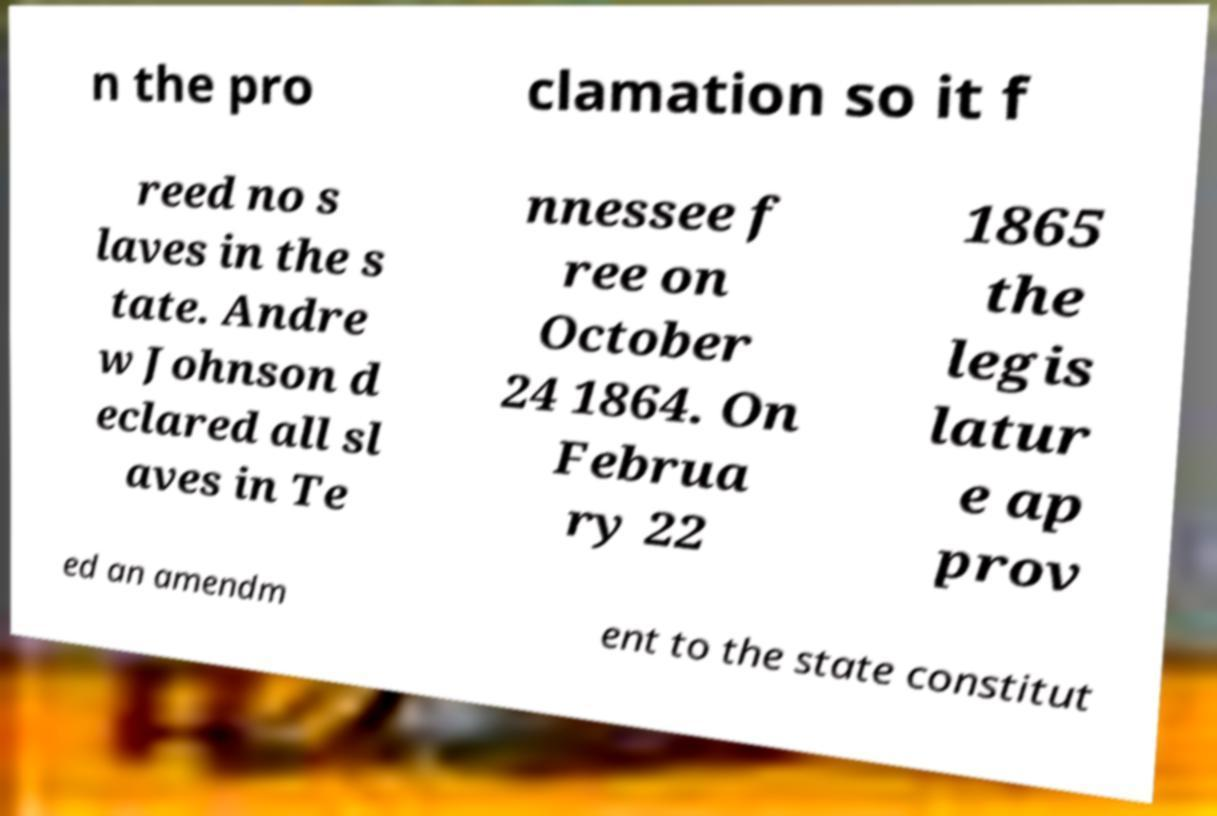For documentation purposes, I need the text within this image transcribed. Could you provide that? n the pro clamation so it f reed no s laves in the s tate. Andre w Johnson d eclared all sl aves in Te nnessee f ree on October 24 1864. On Februa ry 22 1865 the legis latur e ap prov ed an amendm ent to the state constitut 